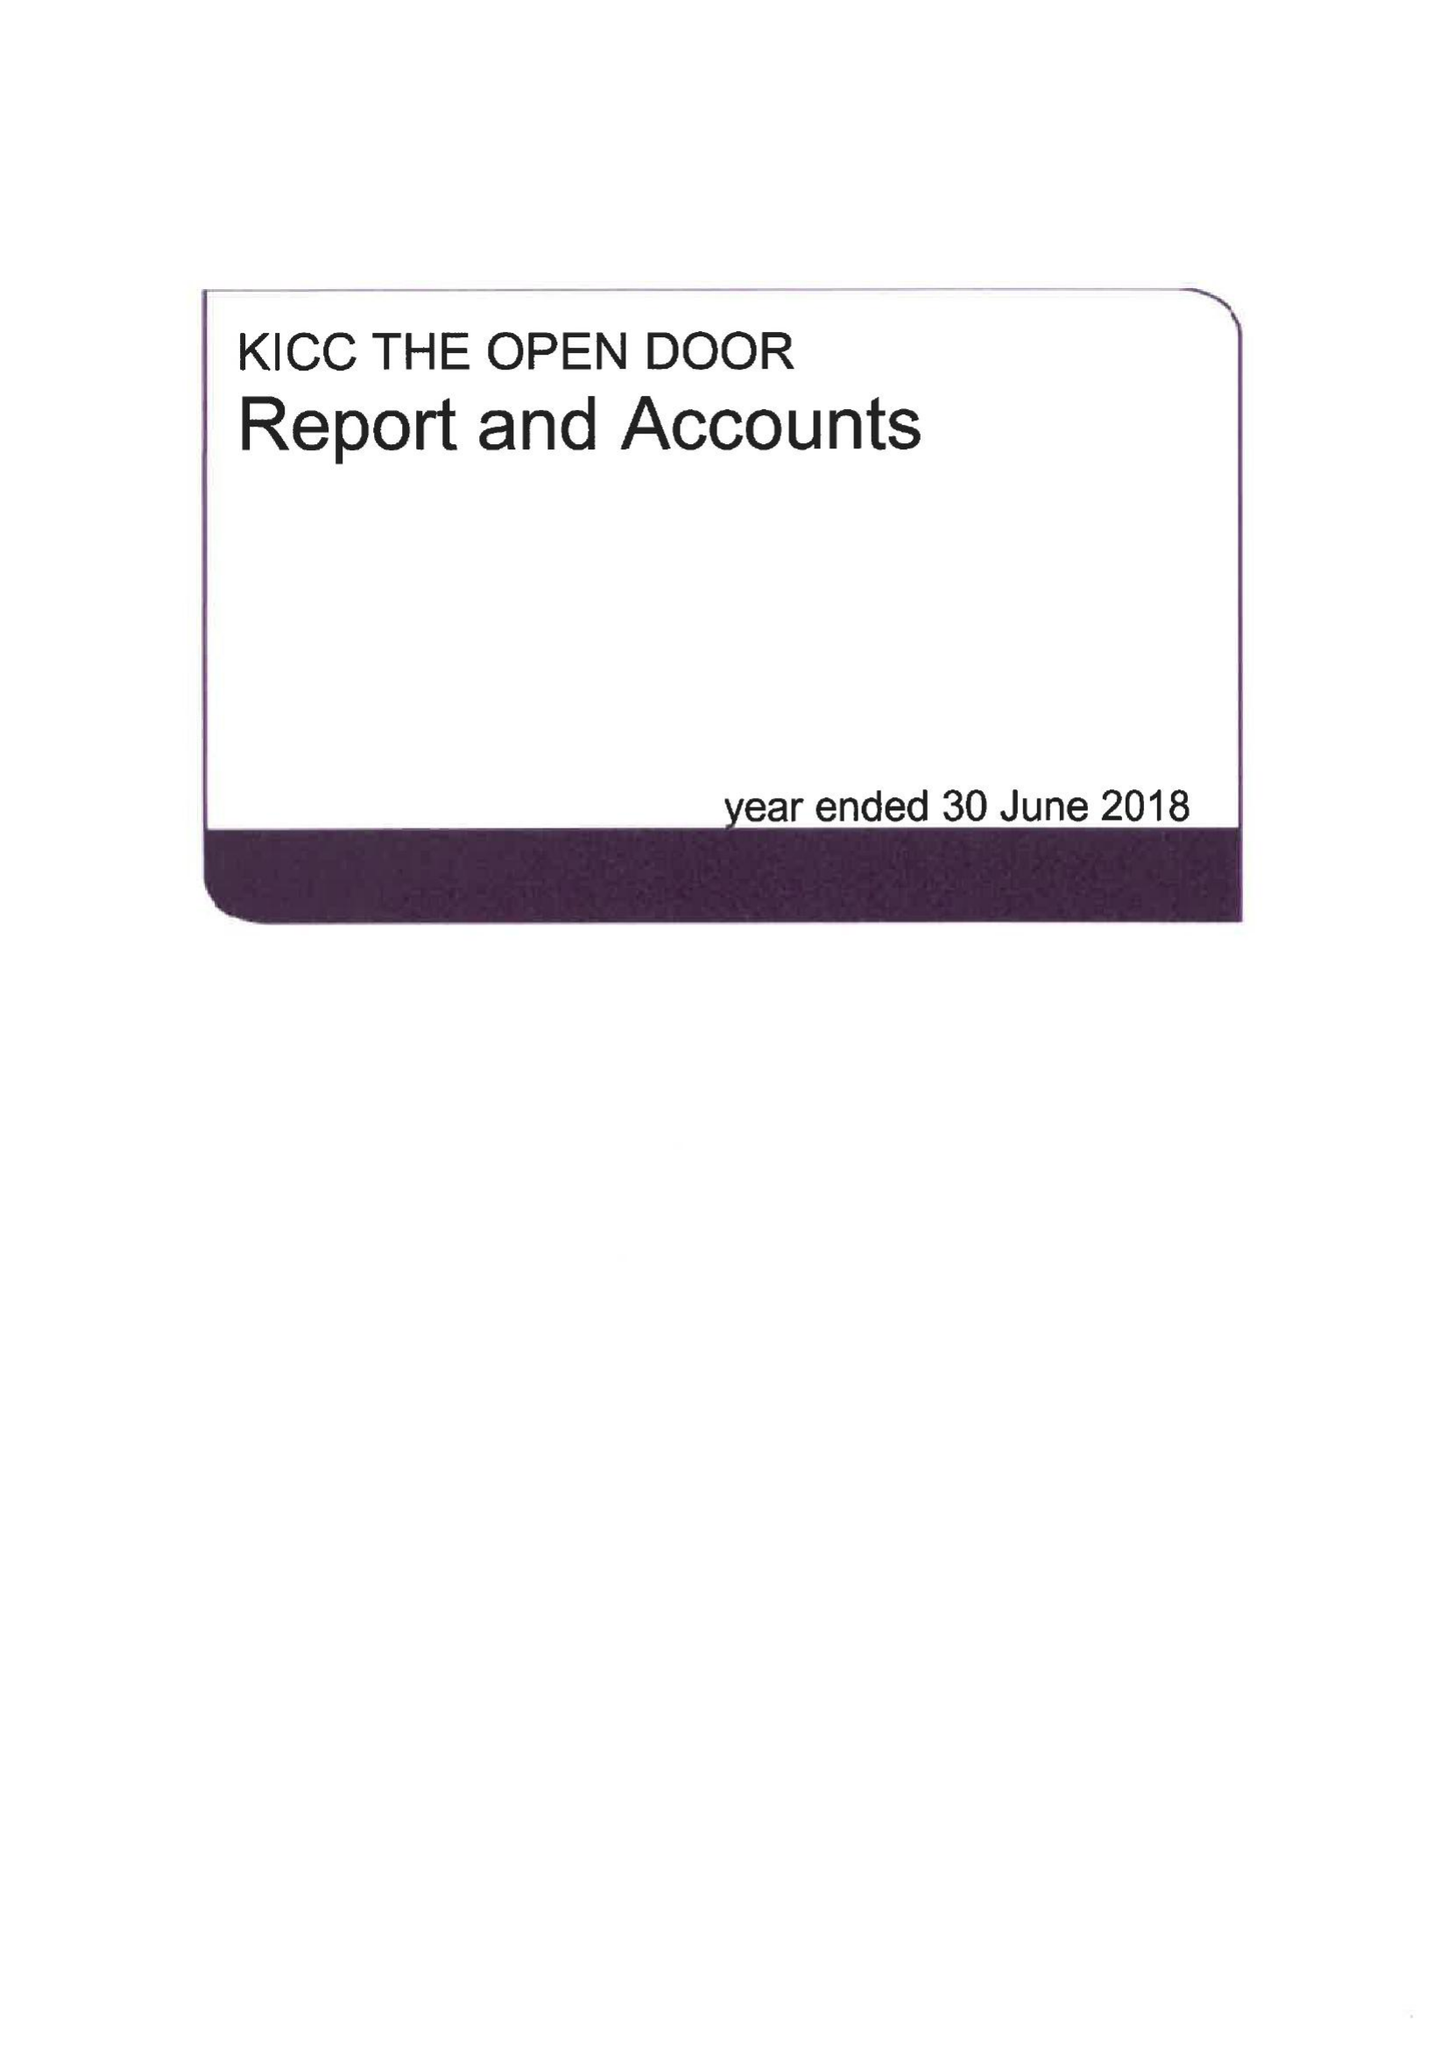What is the value for the address__post_town?
Answer the question using a single word or phrase. LONDON 